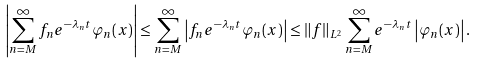Convert formula to latex. <formula><loc_0><loc_0><loc_500><loc_500>\left | \sum _ { n = M } ^ { \infty } f _ { n } e ^ { - \lambda _ { n } t } \varphi _ { n } ( x ) \right | \leq \sum _ { n = M } ^ { \infty } \left | f _ { n } e ^ { - \lambda _ { n } t } \varphi _ { n } ( x ) \right | \leq \| f \| _ { L ^ { 2 } } \sum _ { n = M } ^ { \infty } e ^ { - \lambda _ { n } t } \left | \varphi _ { n } ( x ) \right | .</formula> 